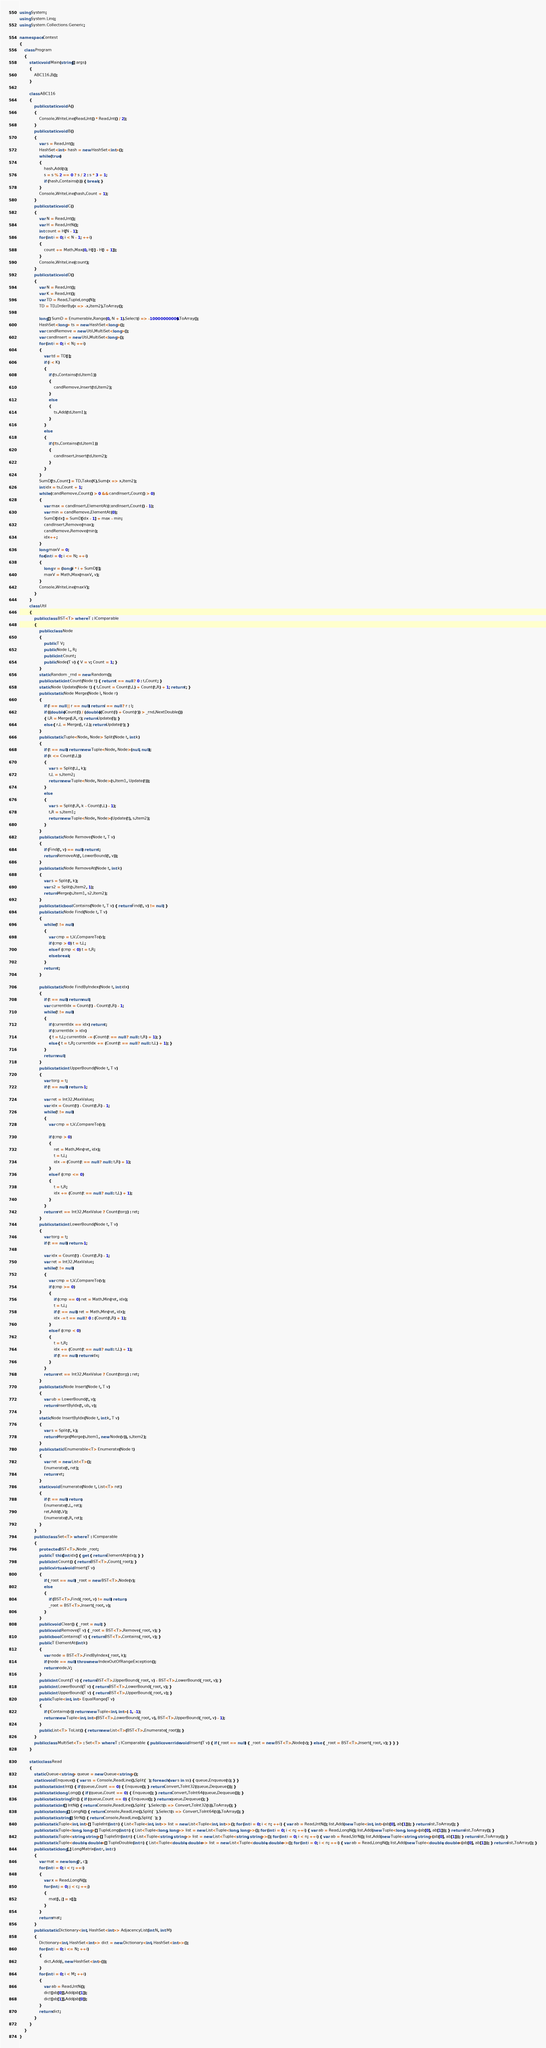<code> <loc_0><loc_0><loc_500><loc_500><_C#_>using System;
using System.Linq;
using System.Collections.Generic;

namespace Contest
{
    class Program
    {
        static void Main(string[] args)
        {
            ABC116.B();
        }

        class ABC116
        {
            public static void A()
            {
                Console.WriteLine(Read.Int() * Read.Int() / 2);
            }
            public static void B()
            {
                var s = Read.Int();
                HashSet<int> hash = new HashSet<int>();
                while (true)
                {
                    hash.Add(s);
                    s = s % 2 == 0 ? s / 2 : s * 3 + 1;
                    if (hash.Contains(s)) { break; }
                }
                Console.WriteLine(hash.Count + 1);
            }
            public static void C()
            {
                var N = Read.Int();
                var H = Read.IntN();
                int count = H[N - 1];
                for (int i = 0; i < N - 1; ++i)
                {
                    count += Math.Max(0, H[i] - H[i + 1]);
                }
                Console.WriteLine(count);
            }
            public static void D()
            {
                var N = Read.Int();
                var K = Read.Int();
                var TD = Read.TupleLong(N);
                TD = TD.OrderBy(x => -x.Item2).ToArray();

                long[] SumD = Enumerable.Range(0, N + 1).Select(i => -10000000000).ToArray();
                HashSet<long> ts = new HashSet<long>();
                var candRemove = new Util.MultiSet<long>();
                var candInsert = new Util.MultiSet<long>();
                for (int i = 0; i < N; ++i)
                {
                    var td = TD[i];
                    if (i < K)
                    {
                        if (ts.Contains(td.Item1))
                        {
                            candRemove.Insert(td.Item2);
                        }
                        else
                        {
                            ts.Add(td.Item1);
                        }
                    }
                    else
                    {
                        if (!ts.Contains(td.Item1))
                        {
                            candInsert.Insert(td.Item2);
                        }
                    }
                }
                SumD[ts.Count] = TD.Take(K).Sum(x => x.Item2);
                int idx = ts.Count + 1;
                while (candRemove.Count() > 0 && candInsert.Count() > 0)
                {
                    var max = candInsert.ElementAt(candInsert.Count() - 1);
                    var min = candRemove.ElementAt(0);
                    SumD[idx] = SumD[idx - 1] + max - min;
                    candInsert.Remove(max);
                    candRemove.Remove(min);
                    idx++;
                }
                long maxV = 0;
                for(int i = 0; i <= N; ++i)
                {
                    long v = (long)i * i + SumD[i];
                    maxV = Math.Max(maxV, v);
                }
                Console.WriteLine(maxV);
            }
        }
        class Util
        {
            public class BST<T> where T : IComparable
            {
                public class Node
                {
                    public T V;
                    public Node L, R;
                    public int Count;
                    public Node(T v) { V = v; Count = 1; }
                }
                static Random _rnd = new Random();
                public static int Count(Node t) { return t == null ? 0 : t.Count; }
                static Node Update(Node t) { t.Count = Count(t.L) + Count(t.R) + 1; return t; }
                public static Node Merge(Node l, Node r)
                {
                    if (l == null || r == null) return l == null ? r : l;
                    if ((double)Count(l) / (double)(Count(l) + Count(r)) > _rnd.NextDouble())
                    { l.R = Merge(l.R, r); return Update(l); }
                    else { r.L = Merge(l, r.L); return Update(r); }
                }
                public static Tuple<Node, Node> Split(Node t, int k)
                {
                    if (t == null) return new Tuple<Node, Node>(null, null);
                    if (k <= Count(t.L))
                    {
                        var s = Split(t.L, k);
                        t.L = s.Item2;
                        return new Tuple<Node, Node>(s.Item1, Update(t));
                    }
                    else
                    {
                        var s = Split(t.R, k - Count(t.L) - 1);
                        t.R = s.Item1;
                        return new Tuple<Node, Node>(Update(t), s.Item2);
                    }
                }
                public static Node Remove(Node t, T v)
                {
                    if (Find(t, v) == null) return t;
                    return RemoveAt(t, LowerBound(t, v));
                }
                public static Node RemoveAt(Node t, int k)
                {
                    var s = Split(t, k);
                    var s2 = Split(s.Item2, 1);
                    return Merge(s.Item1, s2.Item2);
                }
                public static bool Contains(Node t, T v) { return Find(t, v) != null; }
                public static Node Find(Node t, T v)
                {
                    while (t != null)
                    {
                        var cmp = t.V.CompareTo(v);
                        if (cmp > 0) t = t.L;
                        else if (cmp < 0) t = t.R;
                        else break;
                    }
                    return t;
                }

                public static Node FindByIndex(Node t, int idx)
                {
                    if (t == null) return null;
                    var currentIdx = Count(t) - Count(t.R) - 1;
                    while (t != null)
                    {
                        if (currentIdx == idx) return t;
                        if (currentIdx > idx)
                        { t = t.L; currentIdx -= (Count(t == null ? null : t.R) + 1); }
                        else { t = t.R; currentIdx += (Count(t == null ? null : t.L) + 1); }
                    }
                    return null;
                }
                public static int UpperBound(Node t, T v)
                {
                    var torg = t;
                    if (t == null) return -1;

                    var ret = Int32.MaxValue;
                    var idx = Count(t) - Count(t.R) - 1;
                    while (t != null)
                    {
                        var cmp = t.V.CompareTo(v);

                        if (cmp > 0)
                        {
                            ret = Math.Min(ret, idx);
                            t = t.L;
                            idx -= (Count(t == null ? null : t.R) + 1);
                        }
                        else if (cmp <= 0)
                        {
                            t = t.R;
                            idx += (Count(t == null ? null : t.L) + 1);
                        }
                    }
                    return ret == Int32.MaxValue ? Count(torg) : ret;
                }
                public static int LowerBound(Node t, T v)
                {
                    var torg = t;
                    if (t == null) return -1;

                    var idx = Count(t) - Count(t.R) - 1;
                    var ret = Int32.MaxValue;
                    while (t != null)
                    {
                        var cmp = t.V.CompareTo(v);
                        if (cmp >= 0)
                        {
                            if (cmp == 0) ret = Math.Min(ret, idx);
                            t = t.L;
                            if (t == null) ret = Math.Min(ret, idx);
                            idx -= t == null ? 0 : (Count(t.R) + 1);
                        }
                        else if (cmp < 0)
                        {
                            t = t.R;
                            idx += (Count(t == null ? null : t.L) + 1);
                            if (t == null) return idx;
                        }
                    }
                    return ret == Int32.MaxValue ? Count(torg) : ret;
                }
                public static Node Insert(Node t, T v)
                {
                    var ub = LowerBound(t, v);
                    return InsertByIdx(t, ub, v);
                }
                static Node InsertByIdx(Node t, int k, T v)
                {
                    var s = Split(t, k);
                    return Merge(Merge(s.Item1, new Node(v)), s.Item2);
                }
                public static IEnumerable<T> Enumerate(Node t)
                {
                    var ret = new List<T>();
                    Enumerate(t, ret);
                    return ret;
                }
                static void Enumerate(Node t, List<T> ret)
                {
                    if (t == null) return;
                    Enumerate(t.L, ret);
                    ret.Add(t.V);
                    Enumerate(t.R, ret);
                }
            }
            public class Set<T> where T : IComparable
            {
                protected BST<T>.Node _root;
                public T this[int idx] { get { return ElementAt(idx); } }
                public int Count() { return BST<T>.Count(_root); }
                public virtual void Insert(T v)
                {
                    if (_root == null) _root = new BST<T>.Node(v);
                    else
                    {
                        if (BST<T>.Find(_root, v) != null) return;
                        _root = BST<T>.Insert(_root, v);
                    }
                }
                public void Clear() { _root = null; }
                public void Remove(T v) { _root = BST<T>.Remove(_root, v); }
                public bool Contains(T v) { return BST<T>.Contains(_root, v); }
                public T ElementAt(int k)
                {
                    var node = BST<T>.FindByIndex(_root, k);
                    if (node == null) throw new IndexOutOfRangeException();
                    return node.V;
                }
                public int Count(T v) { return BST<T>.UpperBound(_root, v) - BST<T>.LowerBound(_root, v); }
                public int LowerBound(T v) { return BST<T>.LowerBound(_root, v); }
                public int UpperBound(T v) { return BST<T>.UpperBound(_root, v); }
                public Tuple<int, int> EqualRange(T v)
                {
                    if (!Contains(v)) return new Tuple<int, int>(-1, -1);
                    return new Tuple<int, int>(BST<T>.LowerBound(_root, v), BST<T>.UpperBound(_root, v) - 1);
                }
                public List<T> ToList() { return new List<T>(BST<T>.Enumerate(_root)); }
            }
            public class MultiSet<T> : Set<T> where T : IComparable { public override void Insert(T v) { if (_root == null) { _root = new BST<T>.Node(v); } else { _root = BST<T>.Insert(_root, v); } } }
        }

        static class Read
        {
            static Queue<string> queue = new Queue<string>();
            static void Enqueue() { var ss = Console.ReadLine().Split(' '); foreach (var s in ss) { queue.Enqueue(s); } }
            public static int Int() { if (queue.Count == 0) { Enqueue(); } return Convert.ToInt32(queue.Dequeue()); }
            public static long Long() { if (queue.Count == 0) { Enqueue(); } return Convert.ToInt64(queue.Dequeue()); }
            public static string Str() { if (queue.Count == 0) { Enqueue(); } return queue.Dequeue(); }
            public static int[] IntN() { return Console.ReadLine().Split(' ').Select(s => Convert.ToInt32(s)).ToArray(); }
            public static long[] LongN() { return Console.ReadLine().Split(' ').Select(s => Convert.ToInt64(s)).ToArray(); }
            public static string[] StrN() { return Console.ReadLine().Split(' '); }
            public static Tuple<int, int>[] TupleInt(int n) { List<Tuple<int, int>> list = new List<Tuple<int, int>>(); for (int i = 0; i < n; ++i) { var ab = Read.IntN(); list.Add(new Tuple<int, int>(ab[0], ab[1])); } return list.ToArray(); }
            public static Tuple<long, long>[] TupleLong(int n) { List<Tuple<long, long>> list = new List<Tuple<long, long>>(); for (int i = 0; i < n; ++i) { var ab = Read.LongN(); list.Add(new Tuple<long, long>(ab[0], ab[1])); } return list.ToArray(); }
            public static Tuple<string, string>[] TupleStr(int n) { List<Tuple<string, string>> list = new List<Tuple<string, string>>(); for (int i = 0; i < n; ++i) { var ab = Read.StrN(); list.Add(new Tuple<string, string>(ab[0], ab[1])); } return list.ToArray(); }
            public static Tuple<double, double>[] TupleDouble(int n) { List<Tuple<double, double>> list = new List<Tuple<double, double>>(); for (int i = 0; i < n; ++i) { var ab = Read.LongN(); list.Add(new Tuple<double, double>(ab[0], ab[1])); } return list.ToArray(); }
            public static long[,] LongMatrix(int r, int c)
            {
                var mat = new long[r, c];
                for (int i = 0; i < r; ++i)
                {
                    var x = Read.LongN();
                    for (int j = 0; j < c; ++j)
                    {
                        mat[i, j] = x[j];
                    }
                }
                return mat;
            }
            public static Dictionary<int, HashSet<int>> AdjacencyList(int N, int M)
            {
                Dictionary<int, HashSet<int>> dict = new Dictionary<int, HashSet<int>>();
                for (int i = 0; i <= N; ++i)
                {
                    dict.Add(i, new HashSet<int>());
                }
                for (int i = 0; i < M; ++i)
                {
                    var ab = Read.IntN();
                    dict[ab[0]].Add(ab[1]);
                    dict[ab[1]].Add(ab[0]);
                }
                return dict;
            }
        }
    }
}
</code> 